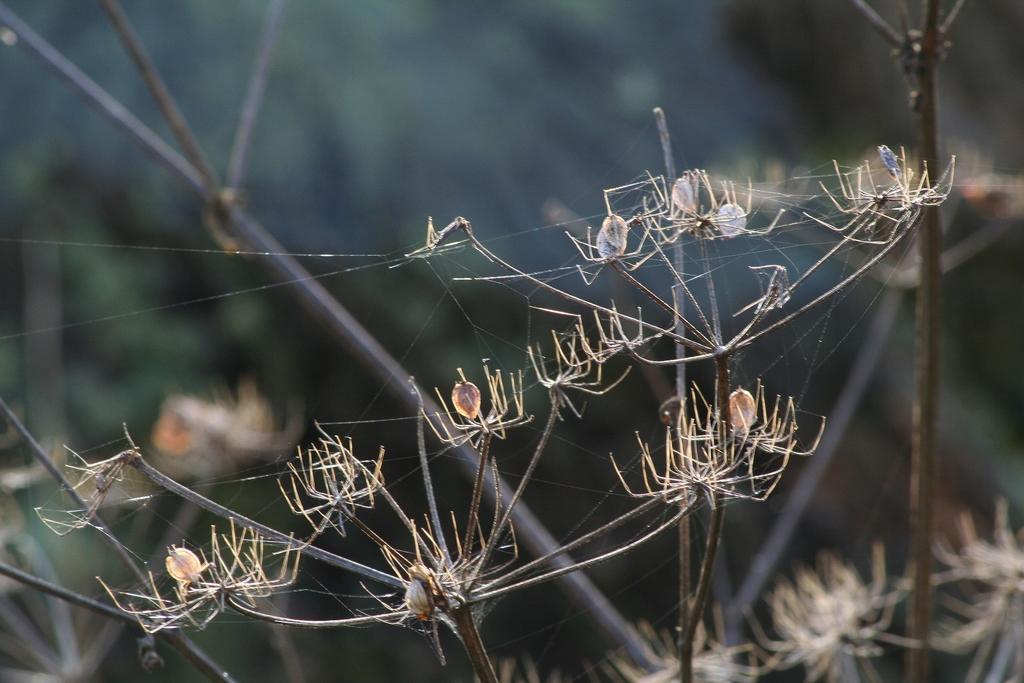Can you describe this image briefly? In this image we can see the spiders on the branches of a tree. 